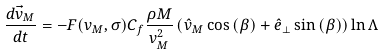<formula> <loc_0><loc_0><loc_500><loc_500>\frac { d \vec { v } _ { M } } { d t } = - F ( v _ { M } , \sigma ) C _ { f } \frac { \rho M } { v _ { M } ^ { 2 } } \left ( \hat { v } _ { M } \cos { ( \beta ) } + \hat { e } _ { \bot } \sin { ( \beta ) } \right ) \ln \Lambda</formula> 